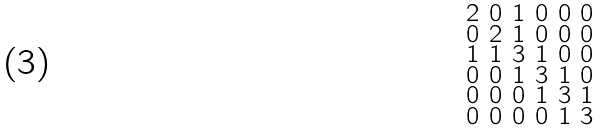Convert formula to latex. <formula><loc_0><loc_0><loc_500><loc_500>\begin{smallmatrix} 2 & 0 & 1 & 0 & 0 & 0 \\ 0 & 2 & 1 & 0 & 0 & 0 \\ 1 & 1 & 3 & 1 & 0 & 0 \\ 0 & 0 & 1 & 3 & 1 & 0 \\ 0 & 0 & 0 & 1 & 3 & 1 \\ 0 & 0 & 0 & 0 & 1 & 3 \end{smallmatrix}</formula> 